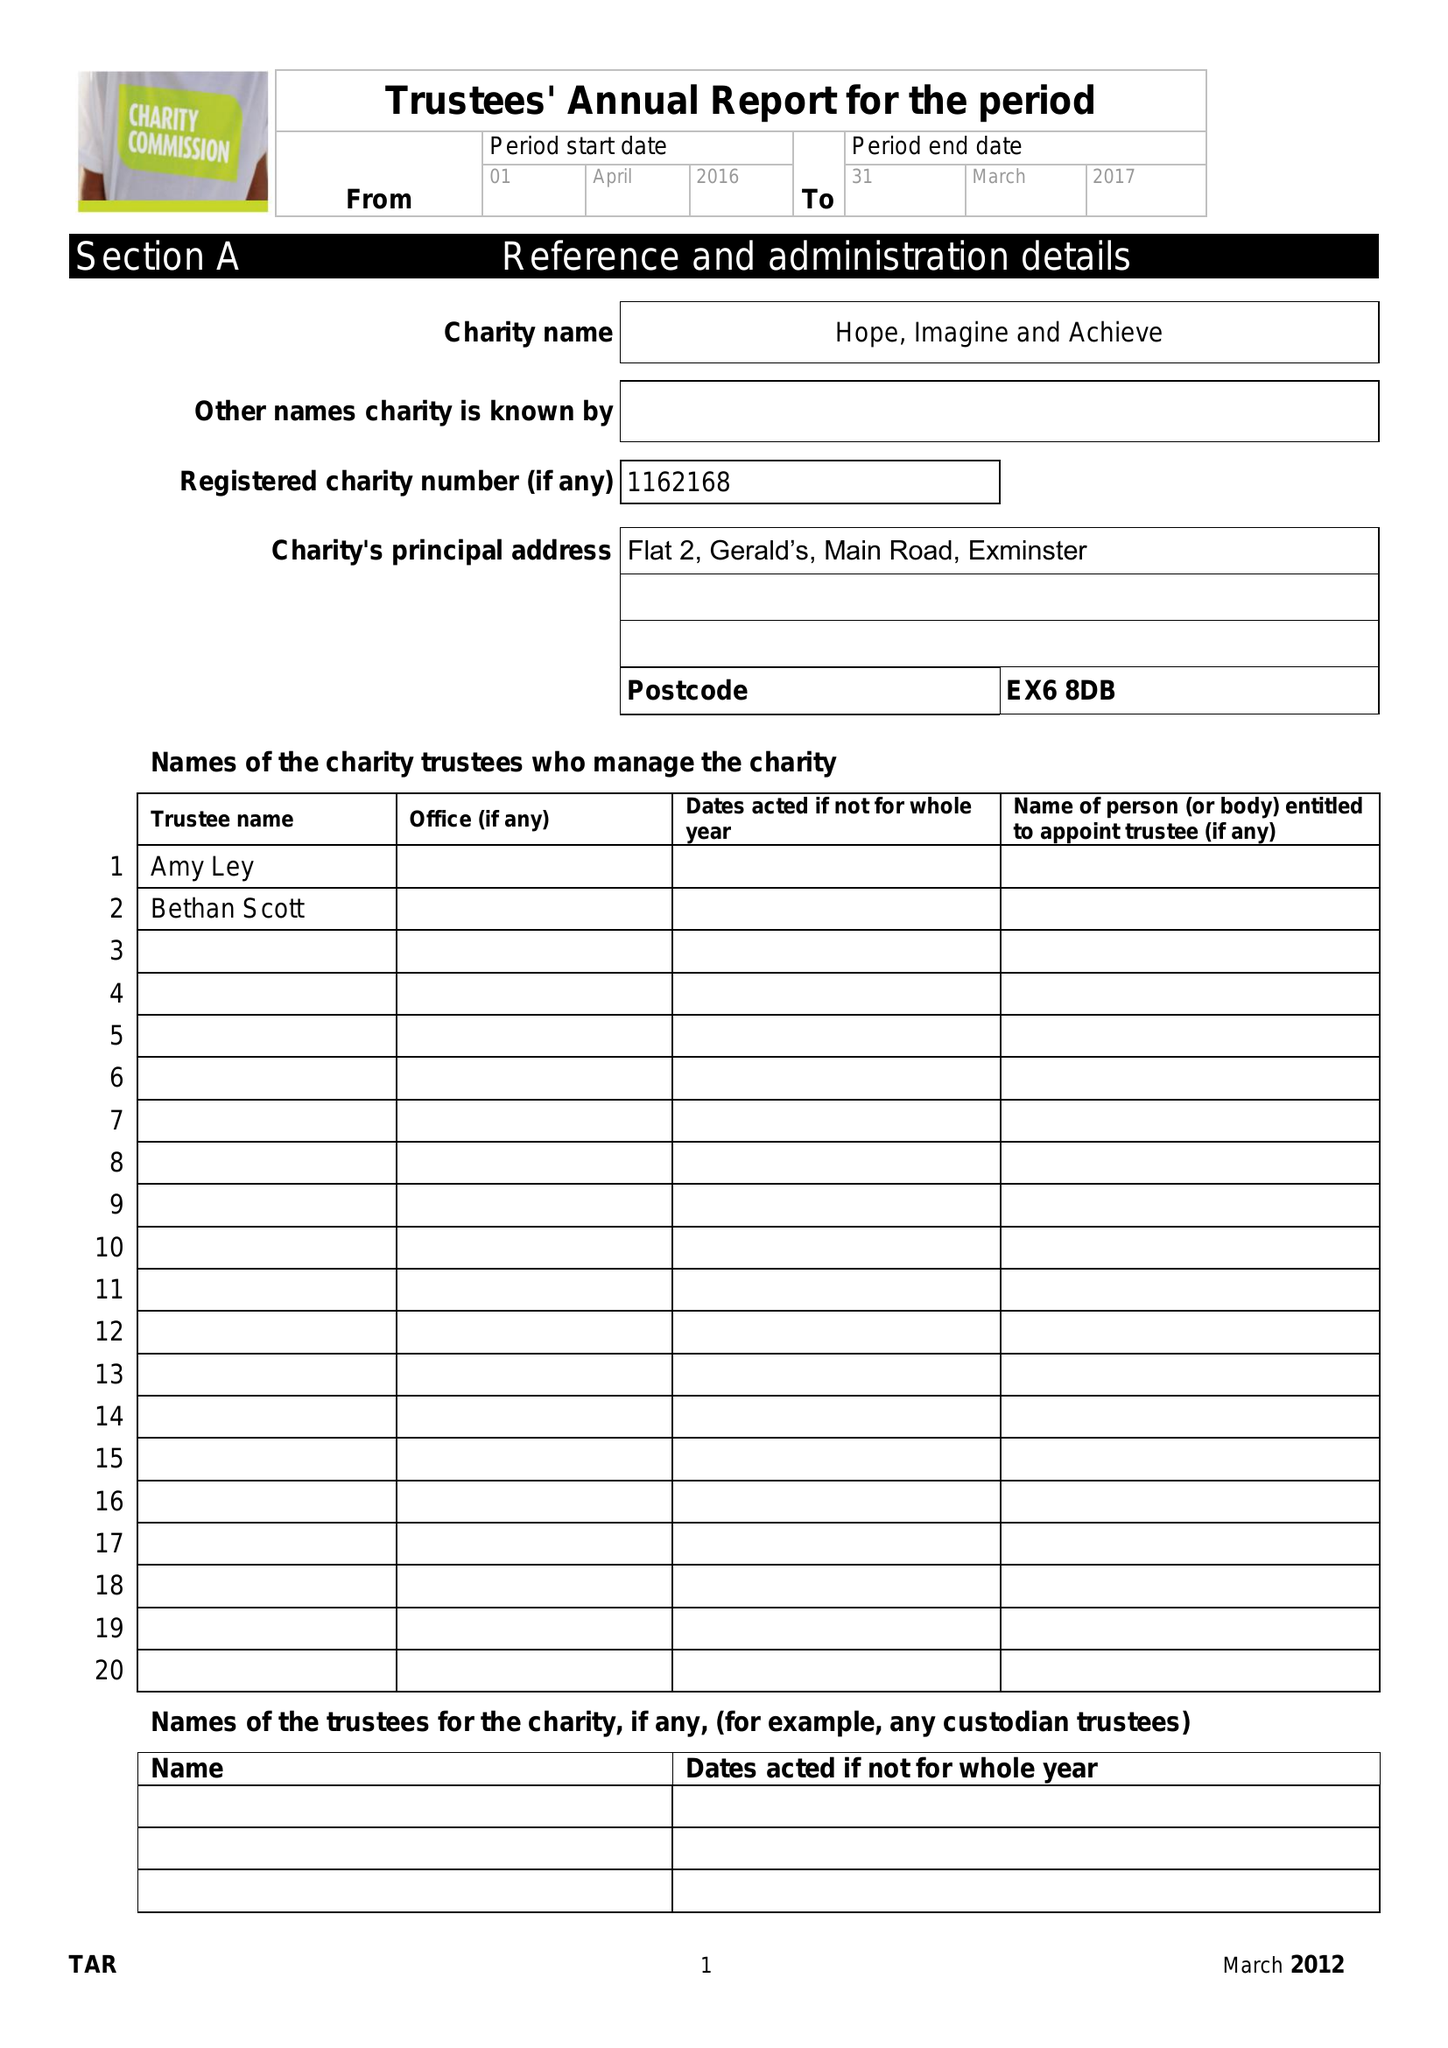What is the value for the spending_annually_in_british_pounds?
Answer the question using a single word or phrase. 665.00 